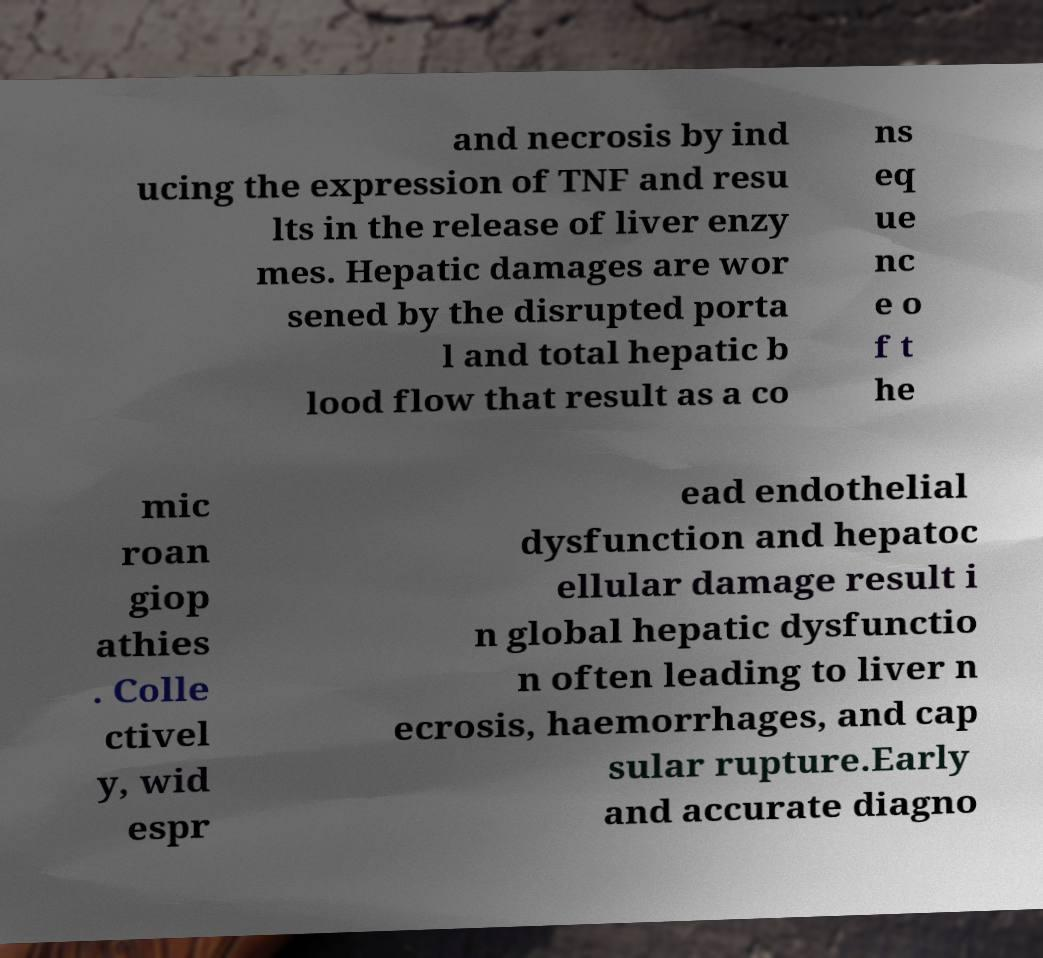Please read and relay the text visible in this image. What does it say? and necrosis by ind ucing the expression of TNF and resu lts in the release of liver enzy mes. Hepatic damages are wor sened by the disrupted porta l and total hepatic b lood flow that result as a co ns eq ue nc e o f t he mic roan giop athies . Colle ctivel y, wid espr ead endothelial dysfunction and hepatoc ellular damage result i n global hepatic dysfunctio n often leading to liver n ecrosis, haemorrhages, and cap sular rupture.Early and accurate diagno 